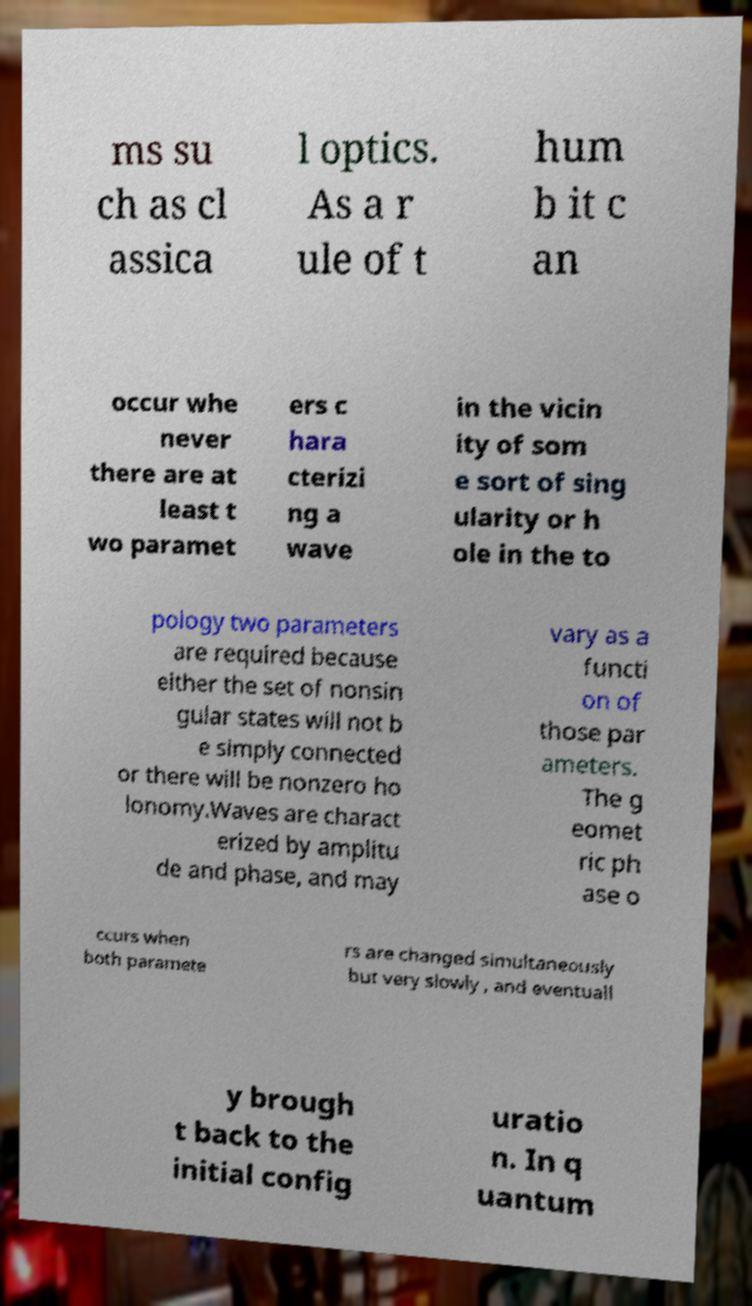Can you accurately transcribe the text from the provided image for me? ms su ch as cl assica l optics. As a r ule of t hum b it c an occur whe never there are at least t wo paramet ers c hara cterizi ng a wave in the vicin ity of som e sort of sing ularity or h ole in the to pology two parameters are required because either the set of nonsin gular states will not b e simply connected or there will be nonzero ho lonomy.Waves are charact erized by amplitu de and phase, and may vary as a functi on of those par ameters. The g eomet ric ph ase o ccurs when both paramete rs are changed simultaneously but very slowly , and eventuall y brough t back to the initial config uratio n. In q uantum 